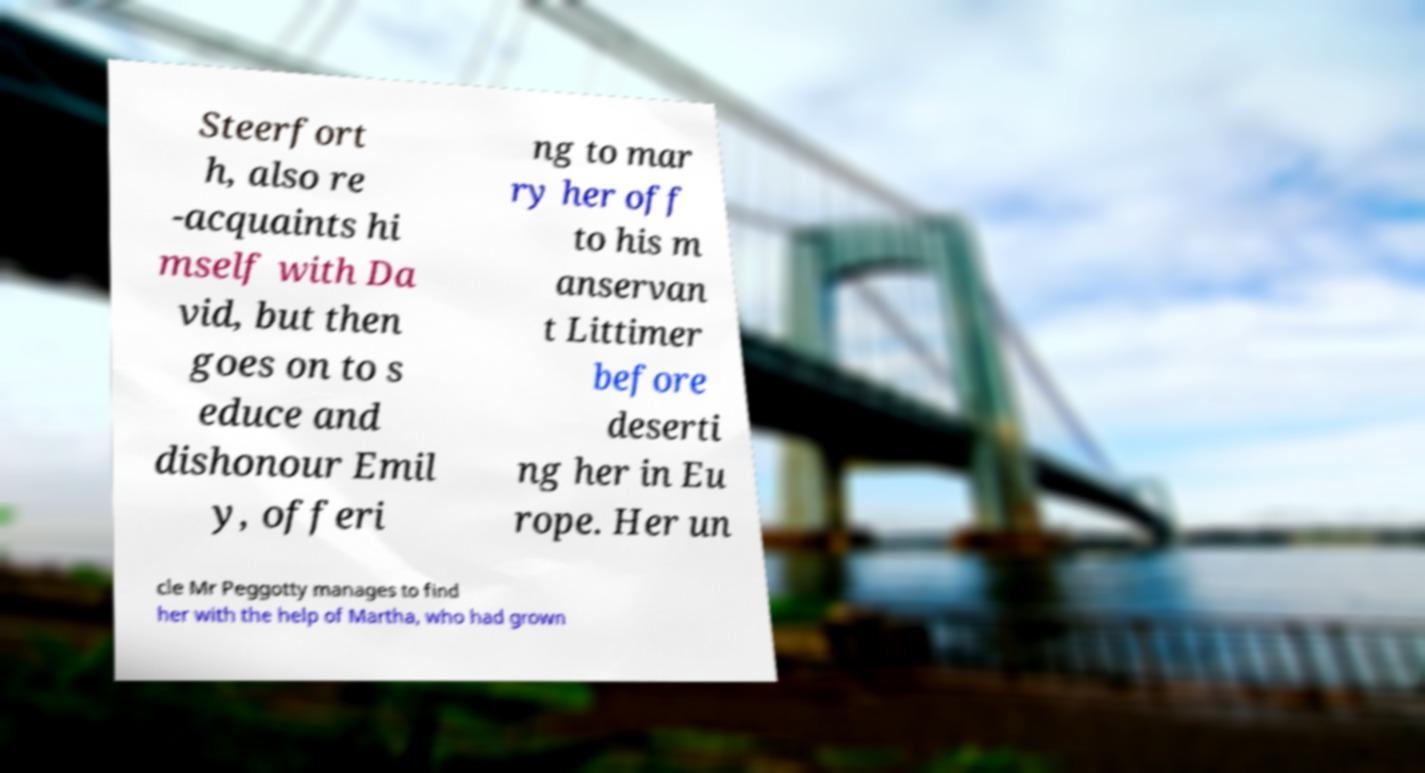Could you extract and type out the text from this image? Steerfort h, also re -acquaints hi mself with Da vid, but then goes on to s educe and dishonour Emil y, offeri ng to mar ry her off to his m anservan t Littimer before deserti ng her in Eu rope. Her un cle Mr Peggotty manages to find her with the help of Martha, who had grown 